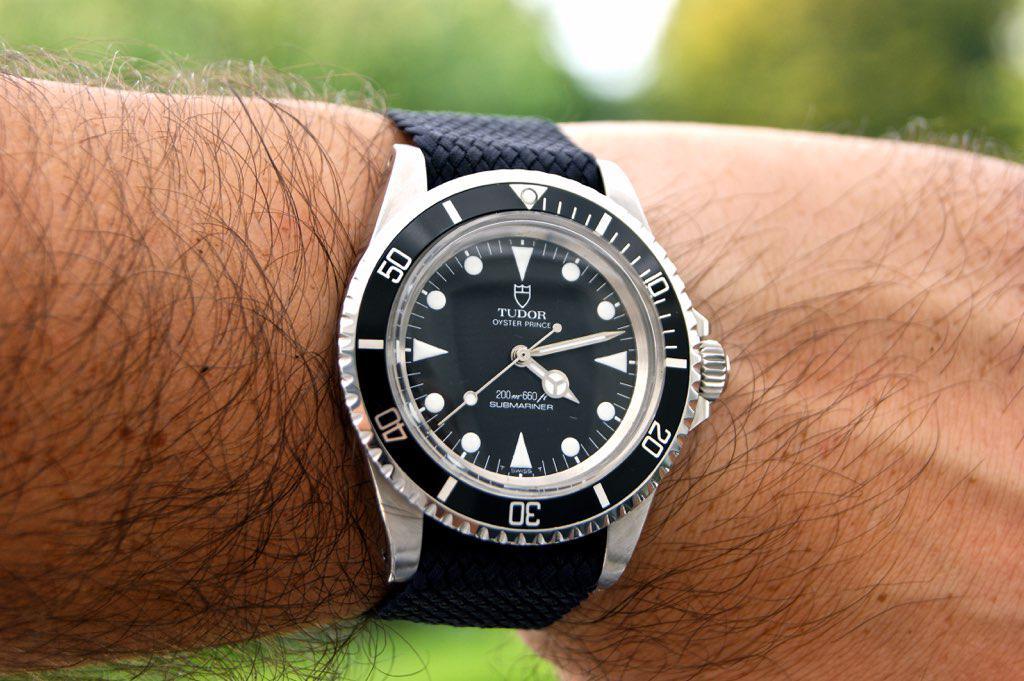What brand is this?
Offer a terse response. Tudor. 